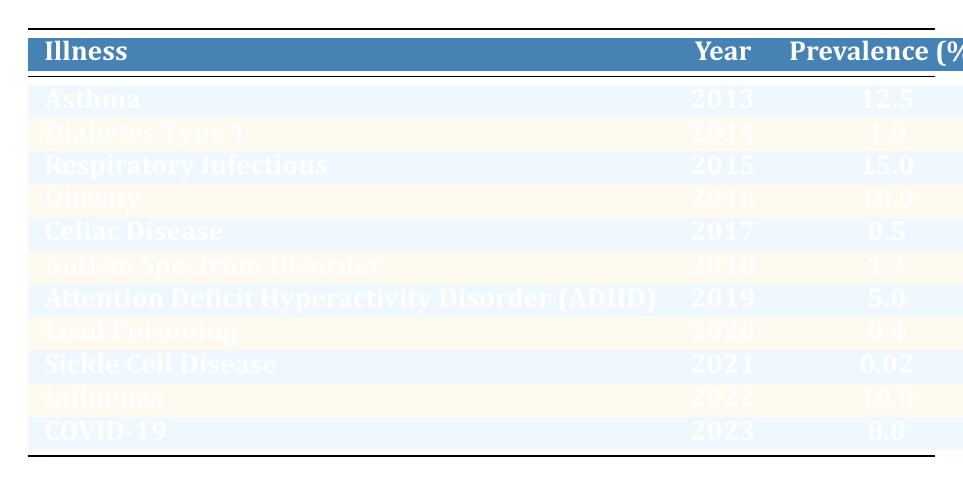What was the prevalence of obesity in 2016? The table shows that in the year 2016, the illness was obesity, and its prevalence is listed as 18.0%.
Answer: 18.0% Which illness had the highest mortality rate in the table? By reviewing the mortality rates, we see that obesity in 2016 had the highest mortality rate of 0.7%.
Answer: 0.7% What is the average prevalence of asthma and respiratory infections across the years listed? The prevalence percentages for asthma (12.5%) and respiratory infections (15.0%) are summed (12.5 + 15.0 = 27.5) and then divided by 2, yielding an average prevalence of 27.5/2 = 13.75%.
Answer: 13.75% Did the prevalence of sickle cell disease exceed 0.1% in 2021? The prevalence of sickle cell disease in 2021 is recorded as 0.02%, which is less than 0.1%.
Answer: No How much higher was the prevalence of asthma in 2013 compared to ADHD in 2019? The prevalence of asthma in 2013 was 12.5% and the prevalence of ADHD in 2019 was 5.0%. The difference is calculated as 12.5 - 5.0 = 7.5%.
Answer: 7.5% Was the mortality rate for influenza in 2022 lower than that for diabetes type 1 in 2014? The mortality rate for influenza in 2022 is 0.02%, and for diabetes type 1 in 2014, it is 0.1%. Since 0.02% is less than 0.1%, the statement is true.
Answer: Yes What was the total prevalence percentage of illnesses recorded from 2013 to 2023? The total prevalence is obtained by summing the individual prevalences from each year: 12.5 + 1.0 + 15.0 + 18.0 + 0.5 + 1.3 + 5.0 + 0.4 + 0.02 + 10.0 + 8.0 = 72.72%.
Answer: 72.72% How did the prevalence of COVID-19 in 2023 compare to that of respiratory infections in 2015? The prevalence of COVID-19 in 2023 is 8.0%, whereas the prevalence of respiratory infections in 2015 is 15.0%. To compare, 8.0% is less than 15.0%.
Answer: Less Which illness had the lowest prevalence over the ten years? Upon inspection, sickle cell disease in 2021 had the lowest prevalence at 0.02%.
Answer: 0.02% 